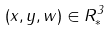Convert formula to latex. <formula><loc_0><loc_0><loc_500><loc_500>( x , y , w ) \in R _ { * } ^ { 3 }</formula> 